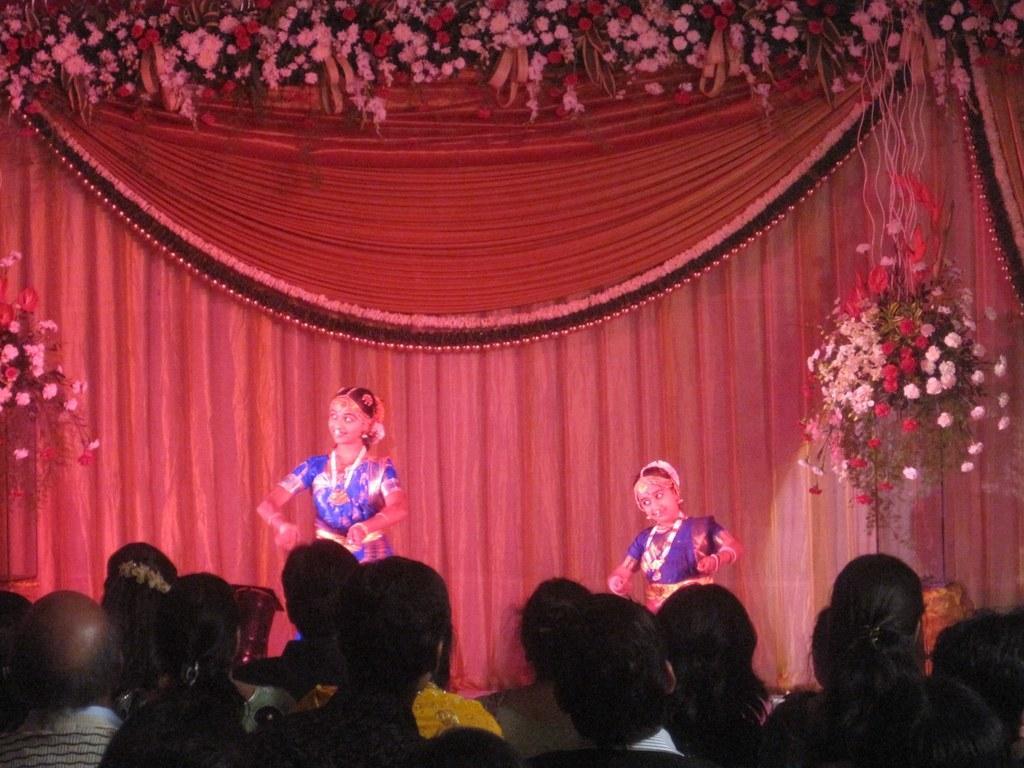Can you describe this image briefly? In this image I can see the group of people wearing the different color dresses. In-front of these people I can see two people dancing. These people are wearing the purple color dresses. In the back I can see the decorative flowers and the curtain. 